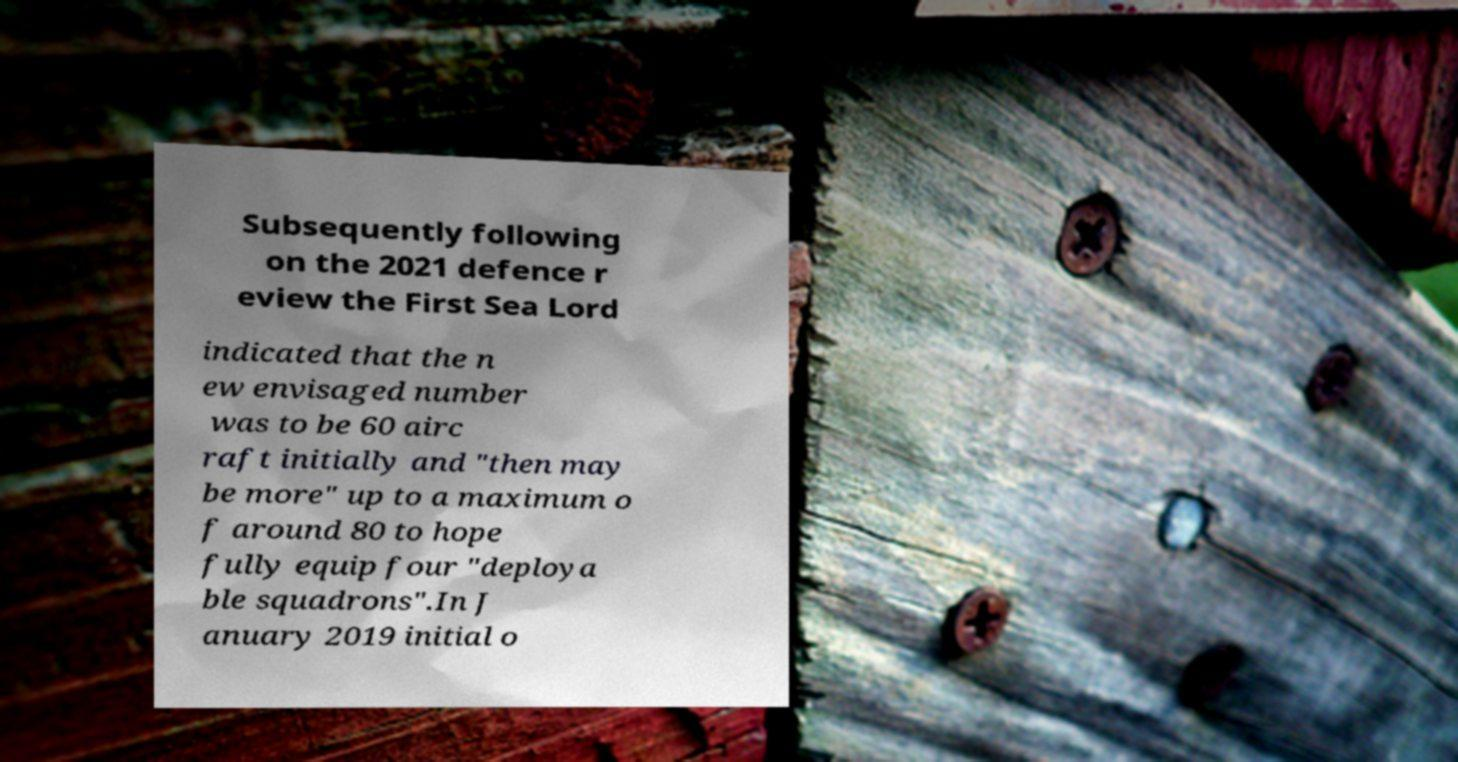Could you extract and type out the text from this image? Subsequently following on the 2021 defence r eview the First Sea Lord indicated that the n ew envisaged number was to be 60 airc raft initially and "then may be more" up to a maximum o f around 80 to hope fully equip four "deploya ble squadrons".In J anuary 2019 initial o 